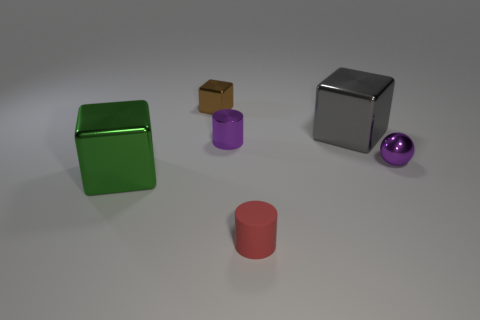The brown shiny object that is the same shape as the green metallic thing is what size?
Ensure brevity in your answer.  Small. Is the number of large green metallic cubes in front of the big green metallic block less than the number of green rubber spheres?
Offer a terse response. No. There is a metallic object right of the big gray metallic cube; what is its size?
Your answer should be very brief. Small. There is another small object that is the same shape as the gray metallic thing; what color is it?
Offer a very short reply. Brown. How many things are the same color as the small metal cylinder?
Make the answer very short. 1. Are there any red rubber objects that are to the right of the thing that is behind the block right of the purple cylinder?
Offer a terse response. Yes. How many small brown cubes are the same material as the green object?
Your response must be concise. 1. Do the purple object that is behind the tiny purple ball and the metal cube that is on the right side of the red matte cylinder have the same size?
Offer a very short reply. No. What color is the metal thing behind the big shiny cube behind the shiny block that is to the left of the brown object?
Offer a terse response. Brown. Is there a small purple thing that has the same shape as the small red matte object?
Provide a short and direct response. Yes. 